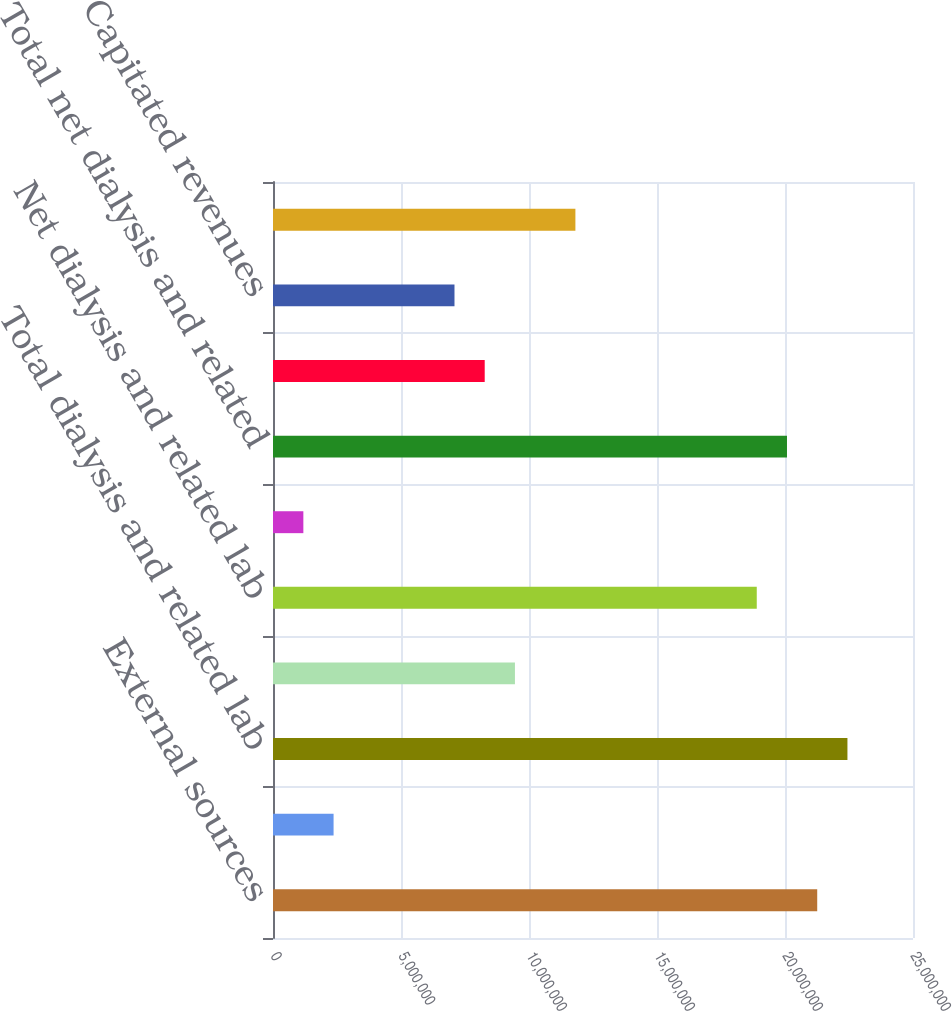Convert chart. <chart><loc_0><loc_0><loc_500><loc_500><bar_chart><fcel>External sources<fcel>Intersegment revenues<fcel>Total dialysis and related lab<fcel>Less Provision for<fcel>Net dialysis and related lab<fcel>Other revenues (1)<fcel>Total net dialysis and related<fcel>Net patient service revenues<fcel>Capitated revenues<fcel>Other external sources<nl><fcel>2.12583e+07<fcel>2.36629e+06<fcel>2.24391e+07<fcel>9.45079e+06<fcel>1.88968e+07<fcel>1.18554e+06<fcel>2.00776e+07<fcel>8.27004e+06<fcel>7.08929e+06<fcel>1.18123e+07<nl></chart> 